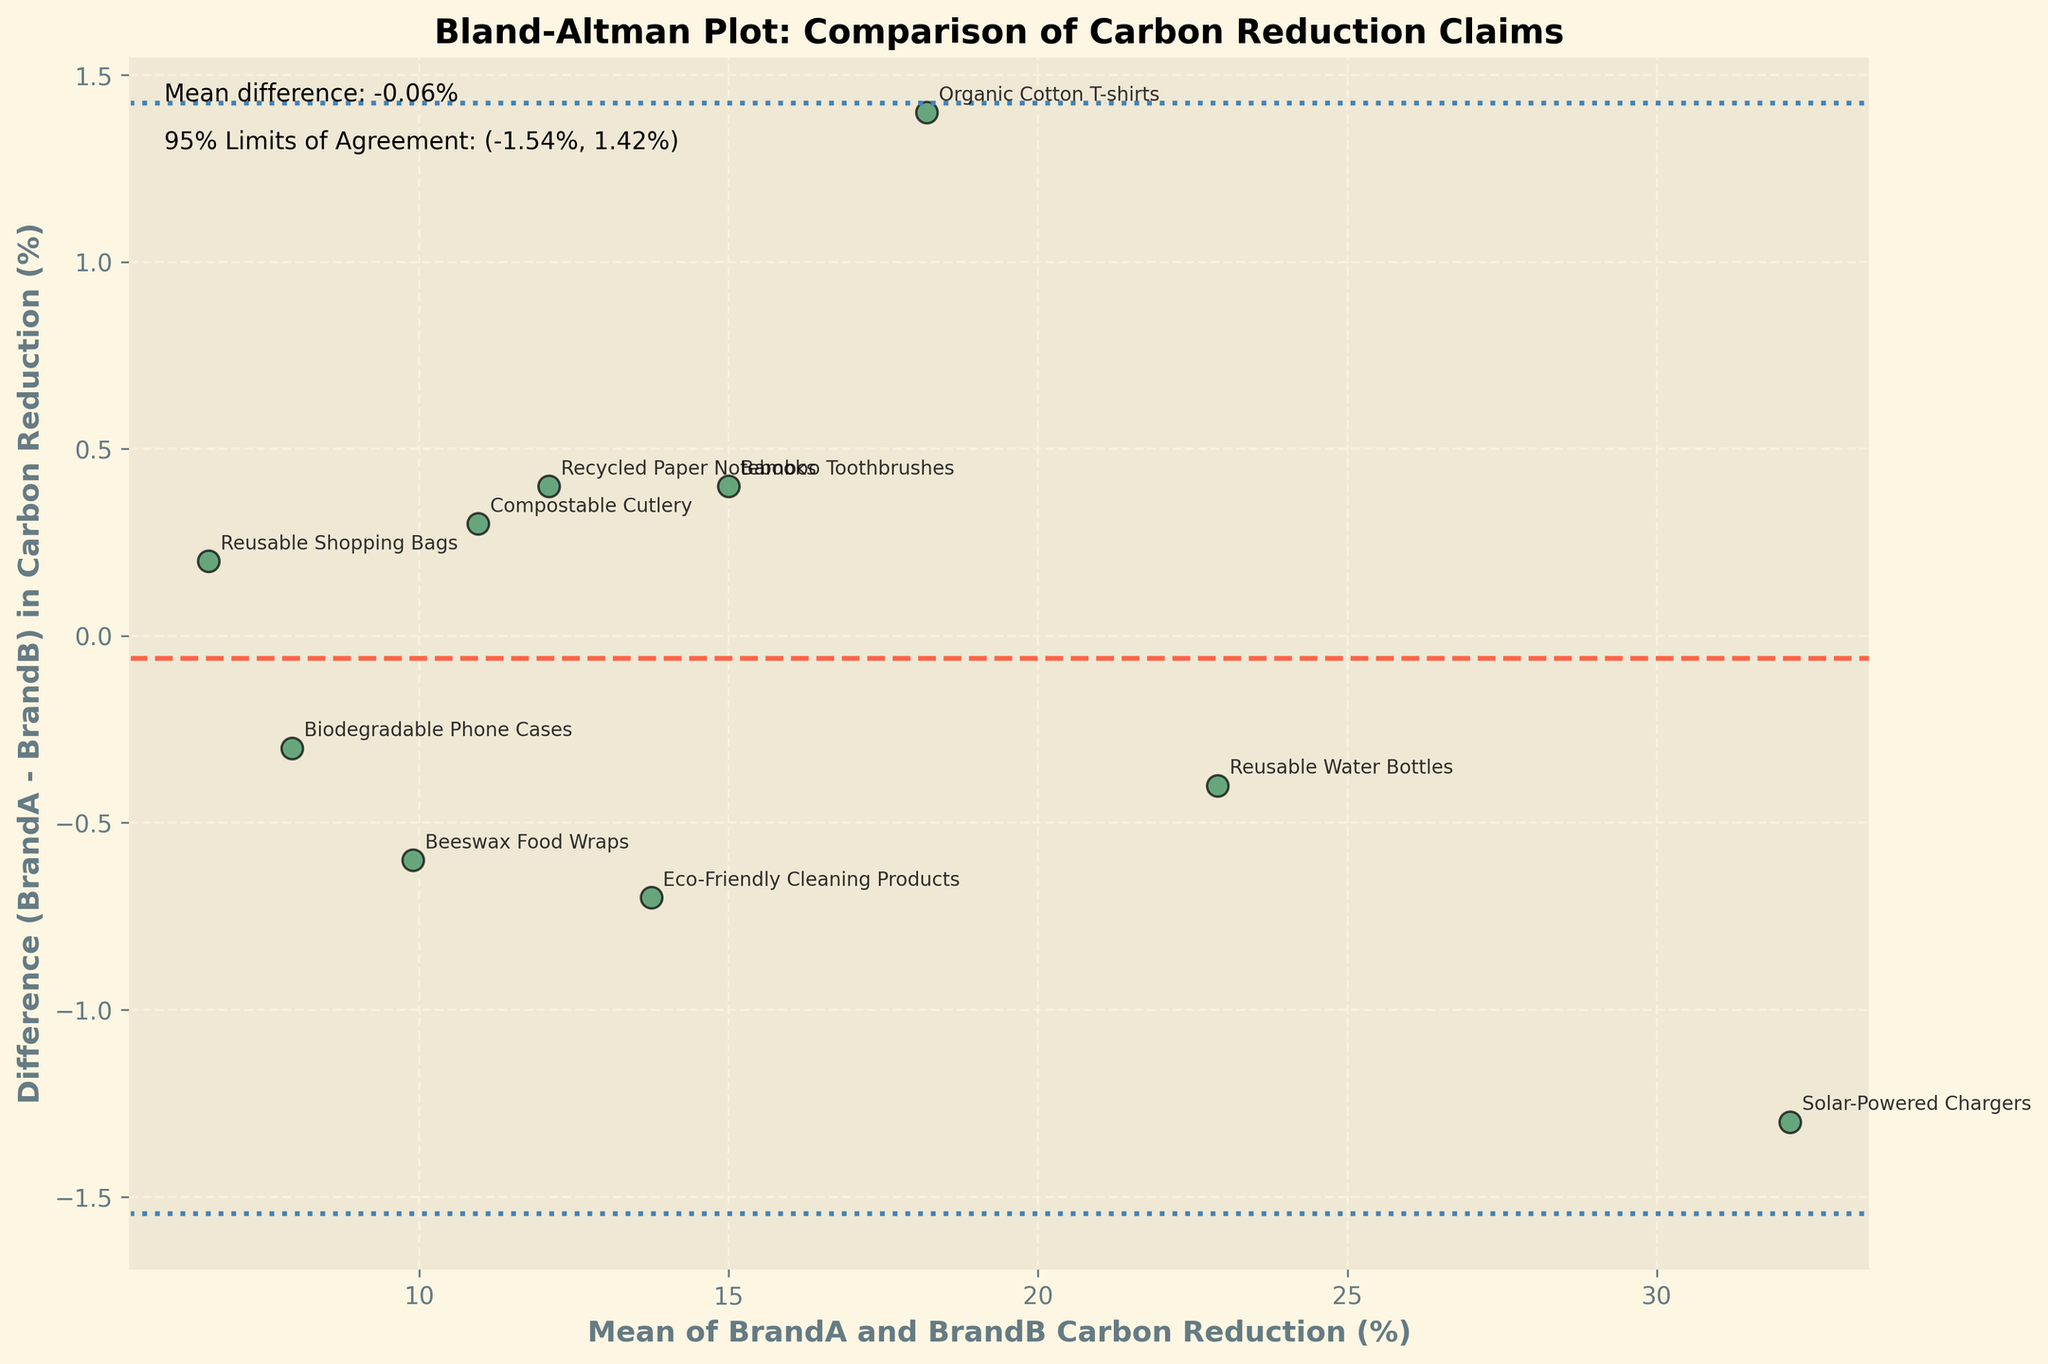What is the title of the plot? The title of the plot is usually displayed at the top of the figure. In this case, it states the purpose of the analysis.
Answer: Bland-Altman Plot: Comparison of Carbon Reduction Claims What does the x-axis represent? The x-axis represents the calculated average of the carbon reduction percentages between the two brands for each product. This is usually derived as the mean of the BrandA and BrandB carbon reduction values.
Answer: Mean of BrandA and BrandB Carbon Reduction (%) What does the y-axis represent? The y-axis represents the difference in carbon reduction percentages between the two brands for each product. This is calculated as the value from BrandA minus the value from BrandB.
Answer: Difference (BrandA - BrandB) in Carbon Reduction (%) How many different products are compared in this plot? Each product has a data point on the plot and is annotated with its name. Counting these annotated labels can give the number of products.
Answer: 10 What is the range of the 95% limits of agreement? The 95% limits of agreement are shown as two horizontal lines, and the exact values are usually annotated near the plot.
Answer: (-1.68%, 2.56%) Which product has the largest positive difference in carbon reduction between BrandA and BrandB? By observing the data points on the y-axis, look for the one with the highest positive y-value. The corresponding label will indicate the product.
Answer: Organic Cotton T-shirts What is the mean difference in the carbon reduction claims between the two brands? The mean difference is represented by a horizontal dashed line, typically annotated near the plot.
Answer: 0.44% For which product do BrandA and BrandB have the closest carbon reduction claim? The product with the data point closest to the y-axis (difference being zero) has the most similar carbon reduction claims between the two brands.
Answer: Reusable Shopping Bags Are there any products where BrandB's carbon reduction claim is higher than BrandA's? If so, name one. Look for any data points on the plot that fall below the zero line on the y-axis. The corresponding product labels indicate these cases.
Answer: Reusable Water Bottles What's the range of mean values for the carbon reduction claims? Calculate the mean of the BrandA and BrandB values for each product, and identify the lowest and highest values from these means. This range is between the minimum and maximum x-axis values.
Answer: 6.6% to 32.15% 